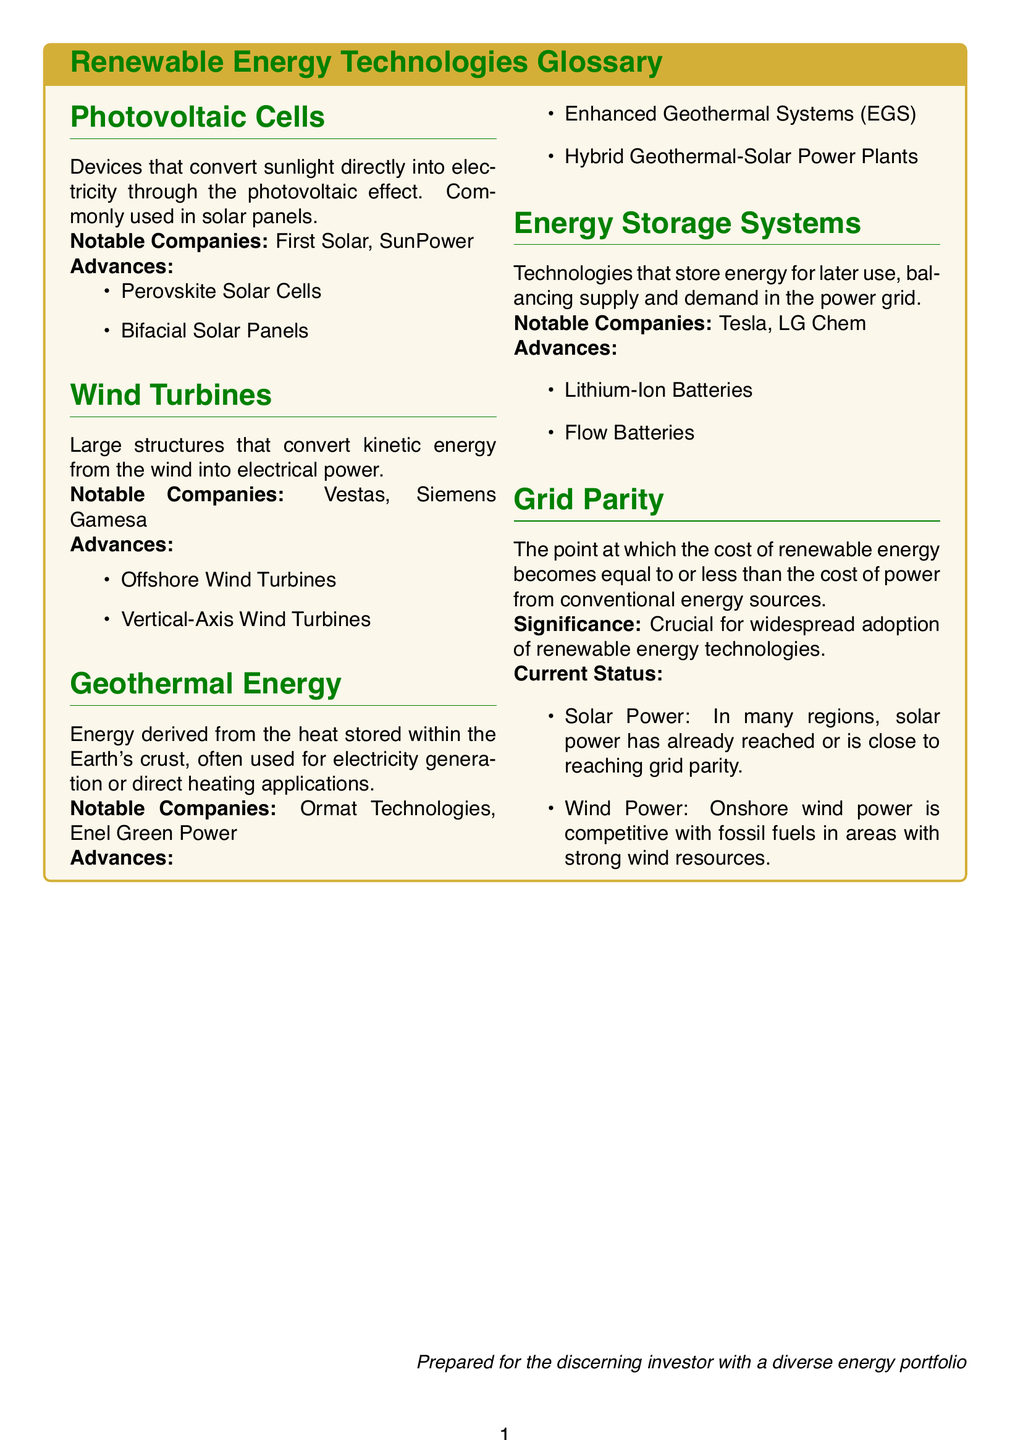What are photovoltaic cells? Photovoltaic cells are devices that convert sunlight directly into electricity through the photovoltaic effect.
Answer: Devices that convert sunlight directly into electricity What notable companies are associated with wind turbines? The document lists the notable companies involved in wind turbines, which are Vestas and Siemens Gamesa.
Answer: Vestas, Siemens Gamesa What is grid parity? Grid parity is the point at which the cost of renewable energy becomes equal to or less than the cost of power from conventional energy sources.
Answer: The point at which the cost of renewable energy becomes equal to or less than fossil fuels What are some advances in geothermal energy? The document mentions Enhanced Geothermal Systems (EGS) and Hybrid Geothermal-Solar Power Plants as advances in geothermal energy.
Answer: Enhanced Geothermal Systems (EGS), Hybrid Geothermal-Solar Power Plants Which technology is used for energy storage systems? The document specifies Lithium-Ion Batteries and Flow Batteries as technologies used for energy storage systems.
Answer: Lithium-Ion Batteries, Flow Batteries What is the significance of grid parity? According to the document, grid parity is crucial for the widespread adoption of renewable energy technologies.
Answer: Crucial for widespread adoption What companies are listed under energy storage systems? The notable companies mentioned for energy storage systems are Tesla and LG Chem.
Answer: Tesla, LG Chem What type of energy is derived from the Earth's crust? The document states that geothermal energy is derived from the heat stored within the Earth's crust.
Answer: Geothermal energy 